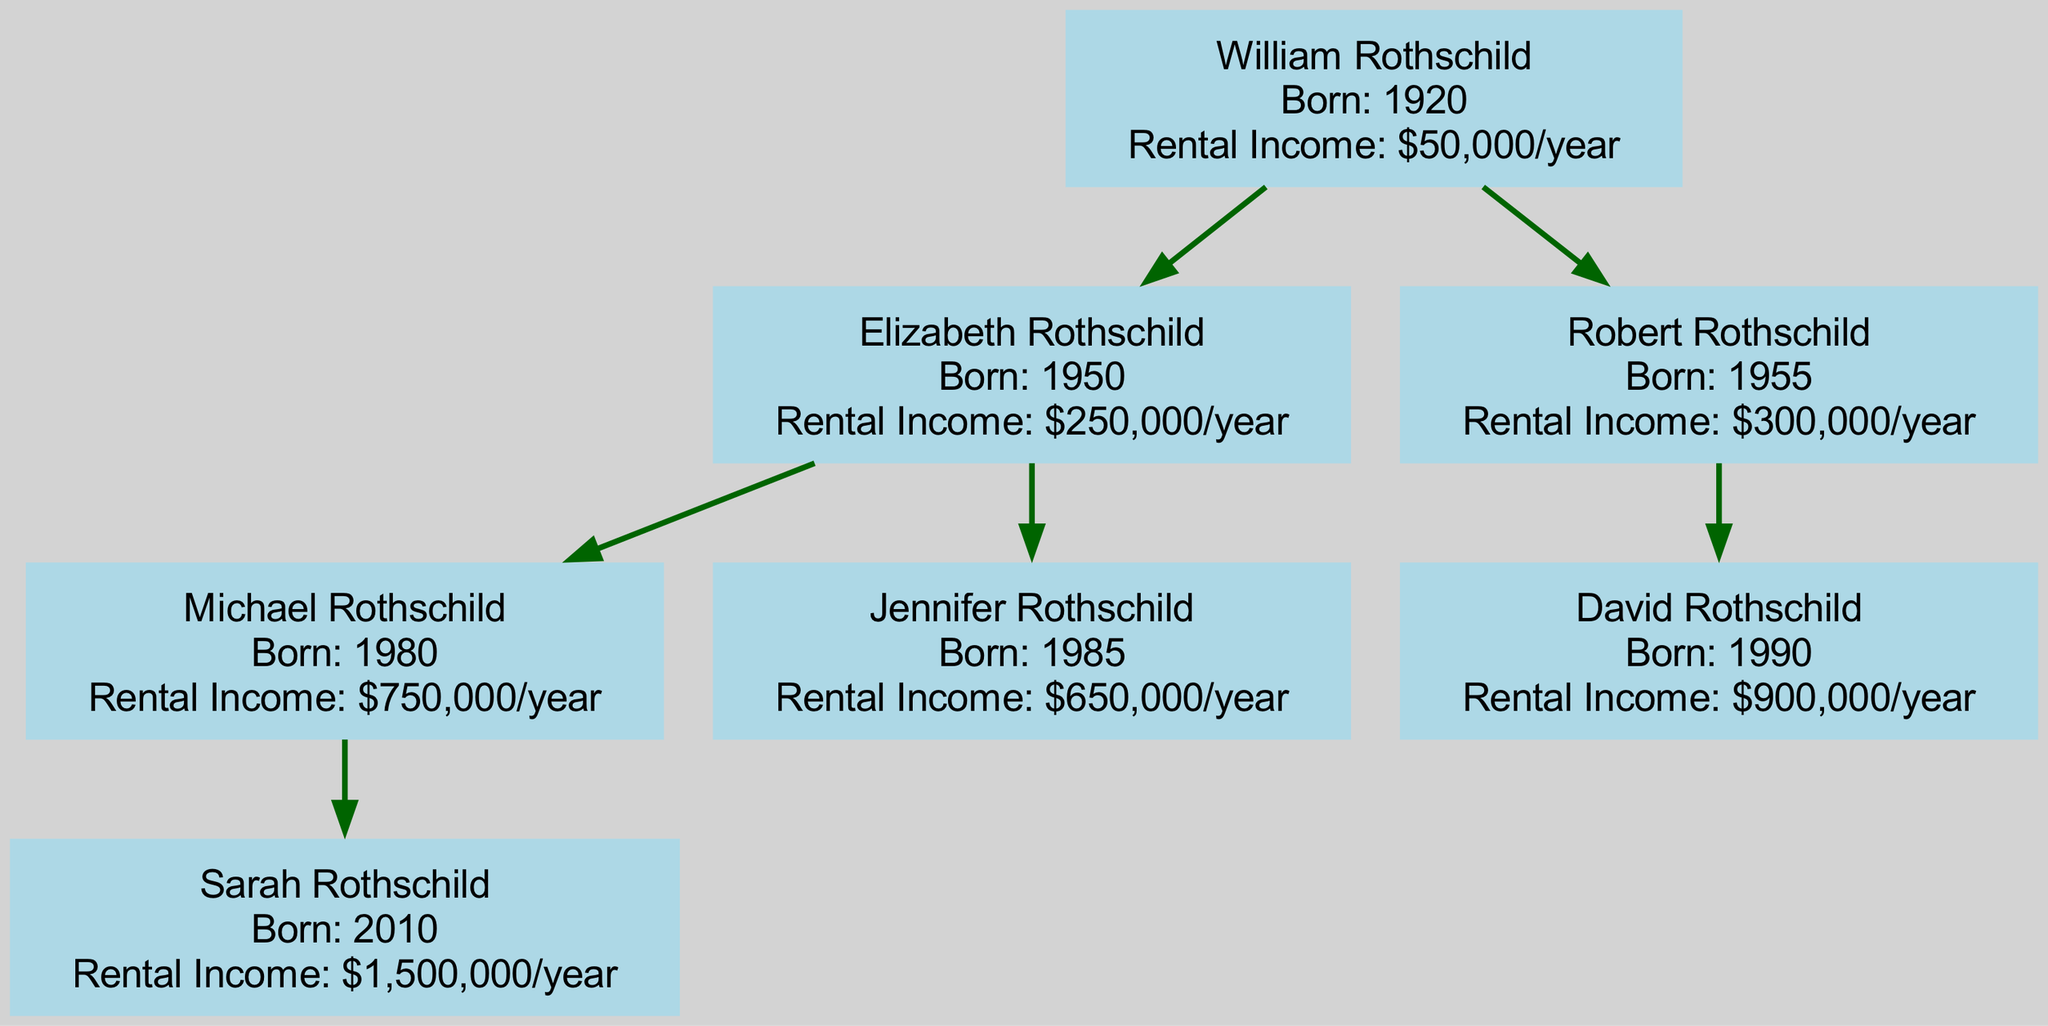What is the birth year of William Rothschild? The diagram indicates that William Rothschild is the root of the family tree. By looking at his details, it shows that he was born in the year 1920.
Answer: 1920 How much rental income does Jennifer Rothschild generate? By examining the information related to Jennifer Rothschild in the diagram, it shows that she generates $650,000 per year in rental income.
Answer: $650,000/year Who is the child of Robert Rothschild? Looking closely at Robert Rothschild in the diagram, we see that his child is David Rothschild, which is explicitly stated in the structure of the family tree.
Answer: David Rothschild What is the total rental income generated by Elizabeth Rothschild and her children? Elizabeth Rothschild generates $250,000 per year. Her children, Michael Rothschild and Jennifer Rothschild, contribute $750,000 and $650,000 respectively. Summing these values gives $250,000 + $750,000 + $650,000 = $1,650,000 per year total.
Answer: $1,650,000/year How many generations are represented in the diagram? The diagram outlines the family tree starting from William Rothschild, representing him as the first generation, followed by his children Elizabeth and Robert as the second generation, and then their children Michael, Jennifer, and David as the third generation. Therefore, there are three generations in total.
Answer: 3 generations Which individual has the highest rental income? Upon examining the rental incomes listed in the diagram, Sarah Rothschild generates the highest rental income at $1,500,000 per year, making her the individual with the highest income among all family members.
Answer: Sarah Rothschild How many children does Elizabeth Rothschild have? By looking at the diagram, it is clear that Elizabeth Rothschild has two children, Michael Rothschild and Jennifer Rothschild, making the total count of her children two.
Answer: 2 children What is Robert Rothschild's rental income? The diagram states that Robert Rothschild generates a rental income of $300,000 per year, which provides a direct answer to the question regarding his income.
Answer: $300,000/year 